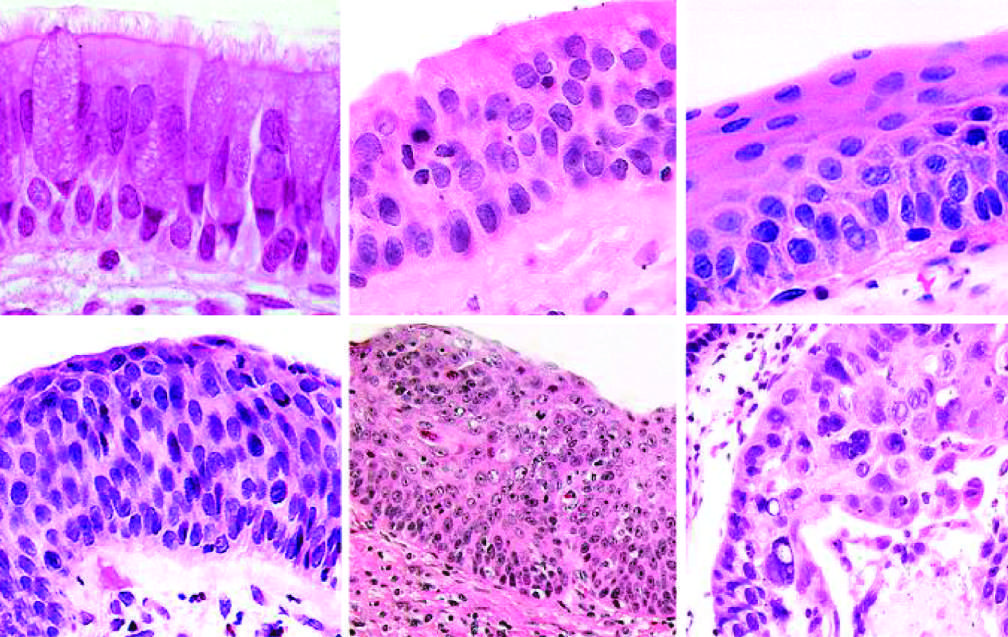re a majority of the tumor cells similar to those in frank carcinoma apart from the lack of basement membrane disruption in cis?
Answer the question using a single word or phrase. No 